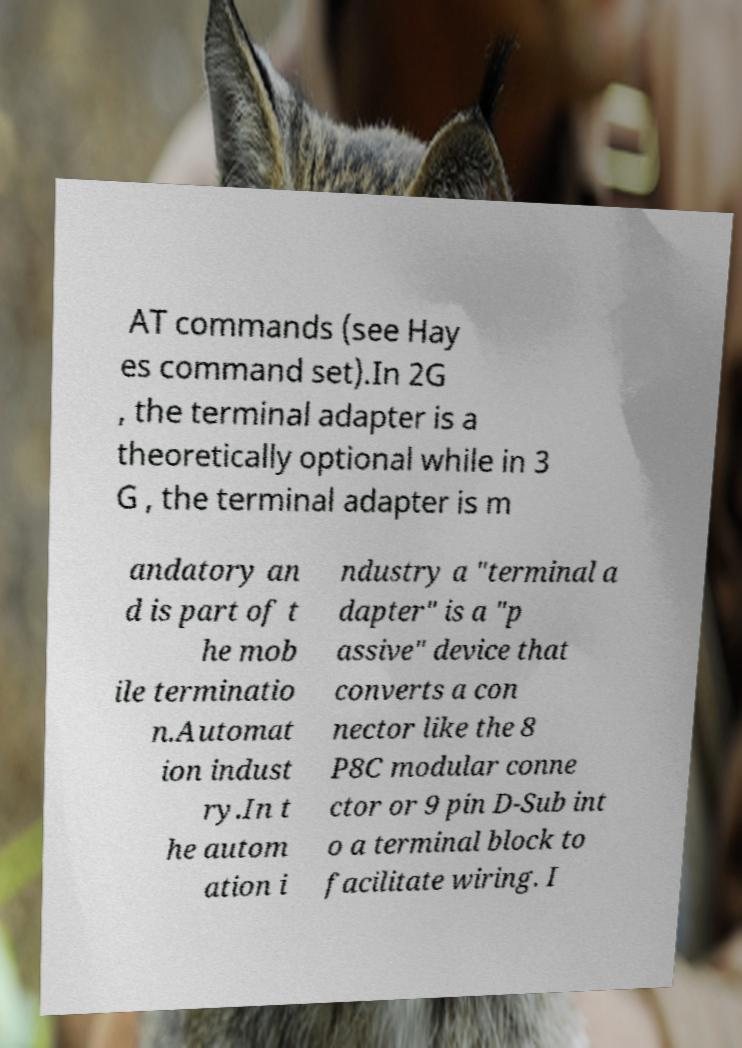Please identify and transcribe the text found in this image. AT commands (see Hay es command set).In 2G , the terminal adapter is a theoretically optional while in 3 G , the terminal adapter is m andatory an d is part of t he mob ile terminatio n.Automat ion indust ry.In t he autom ation i ndustry a "terminal a dapter" is a "p assive" device that converts a con nector like the 8 P8C modular conne ctor or 9 pin D-Sub int o a terminal block to facilitate wiring. I 